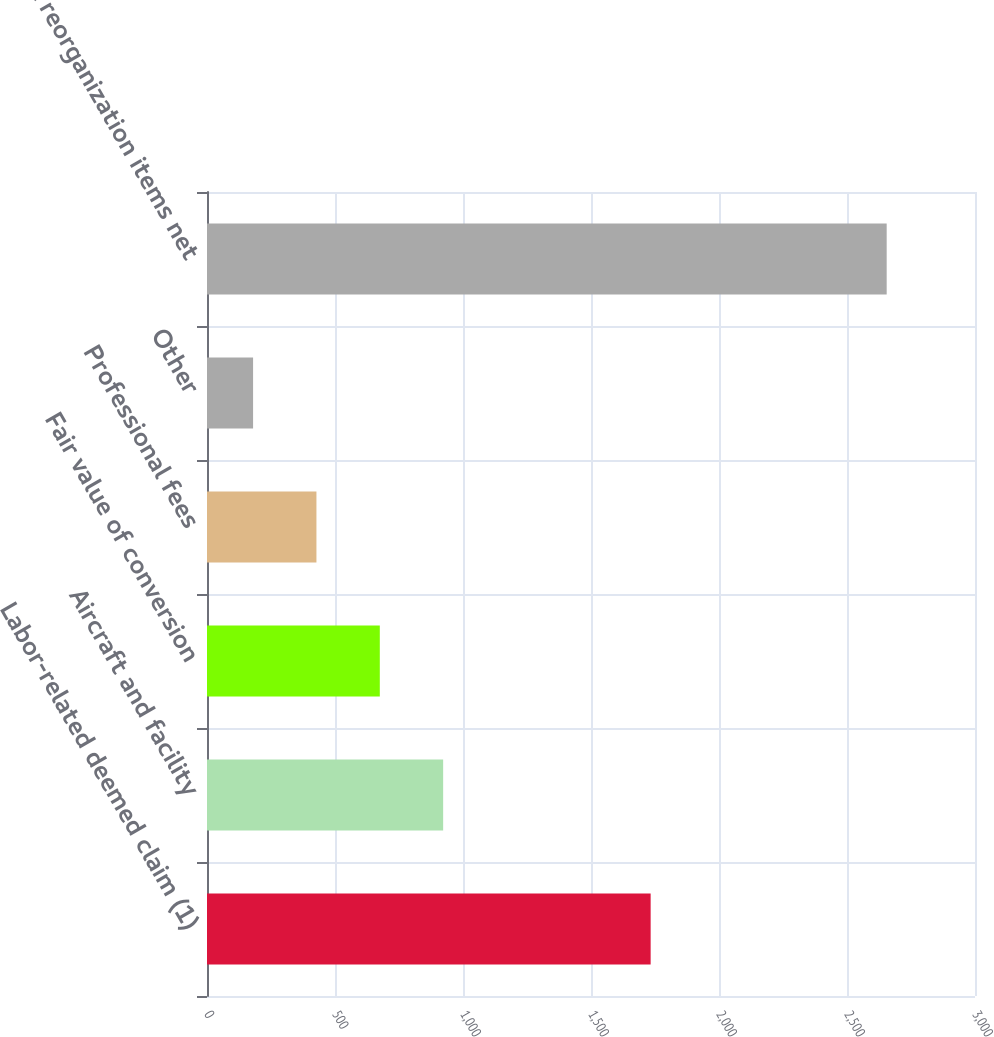Convert chart. <chart><loc_0><loc_0><loc_500><loc_500><bar_chart><fcel>Labor-related deemed claim (1)<fcel>Aircraft and facility<fcel>Fair value of conversion<fcel>Professional fees<fcel>Other<fcel>Total reorganization items net<nl><fcel>1733<fcel>922.5<fcel>675<fcel>427.5<fcel>180<fcel>2655<nl></chart> 